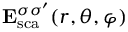Convert formula to latex. <formula><loc_0><loc_0><loc_500><loc_500>E _ { s c a } ^ { \sigma \sigma ^ { \prime } } ( r , \theta , \varphi )</formula> 